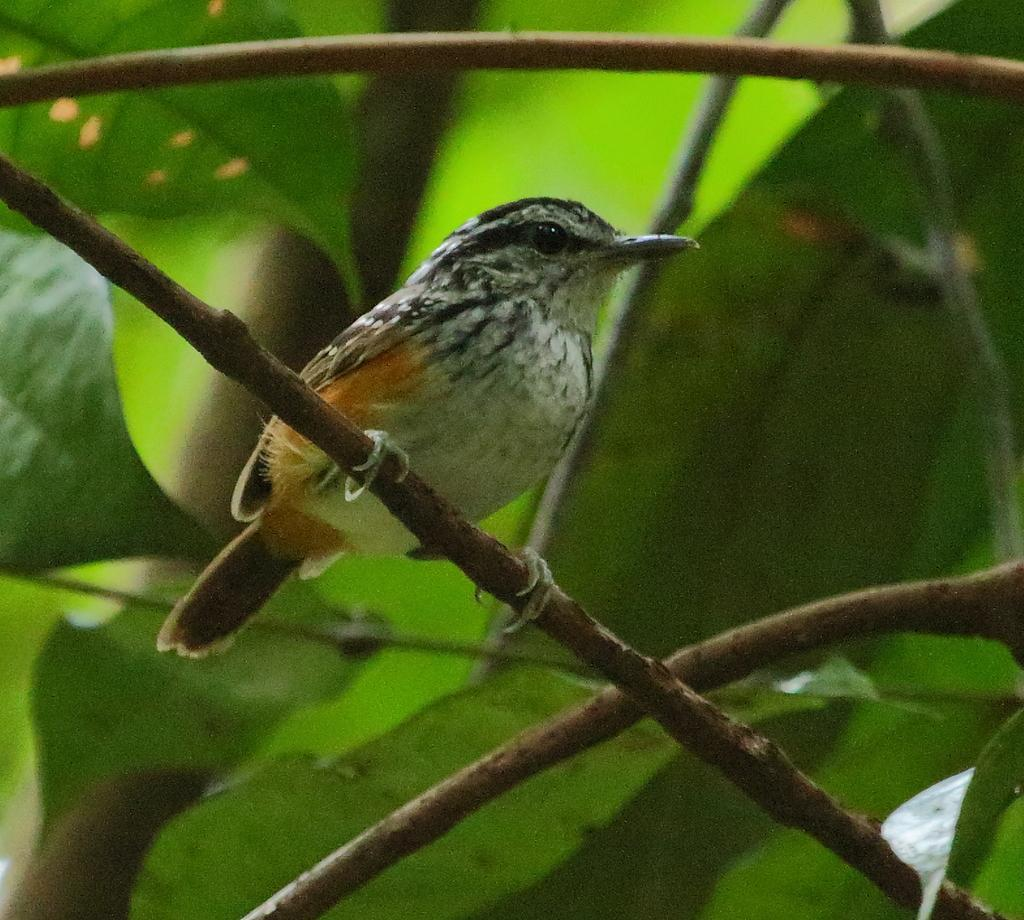What is the main subject of the picture? The main subject of the picture is a sparrow. Where is the sparrow located in the image? The sparrow is on a stem in the center of the picture. What can be seen in the background of the image? There are branches and leaves of a tree in the background of the image. What type of rings can be seen on the sparrow's legs in the image? There are no rings visible on the sparrow's legs in the image. Is there a throne present in the image? There is no throne present in the image; it features a sparrow on a stem with branches and leaves in the background. 